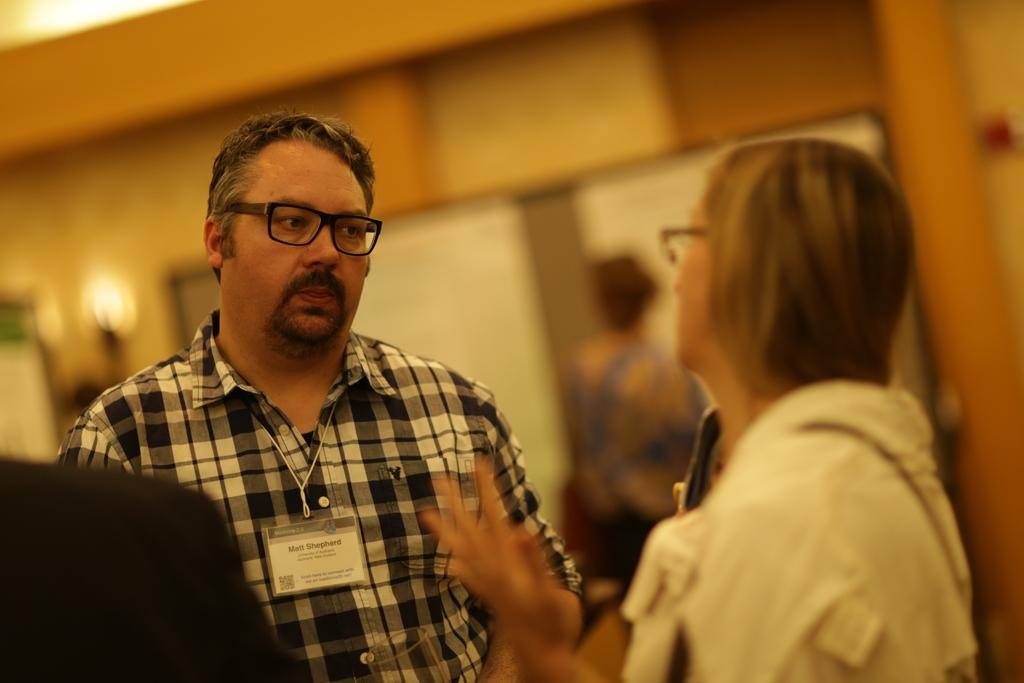What is happening in the image? There are people standing in the image. Can you describe the background of the image? The background of the image is blurred. How many letters are being blown by the wind in the image? There are no letters present in the image, so they cannot be blown by the wind. 